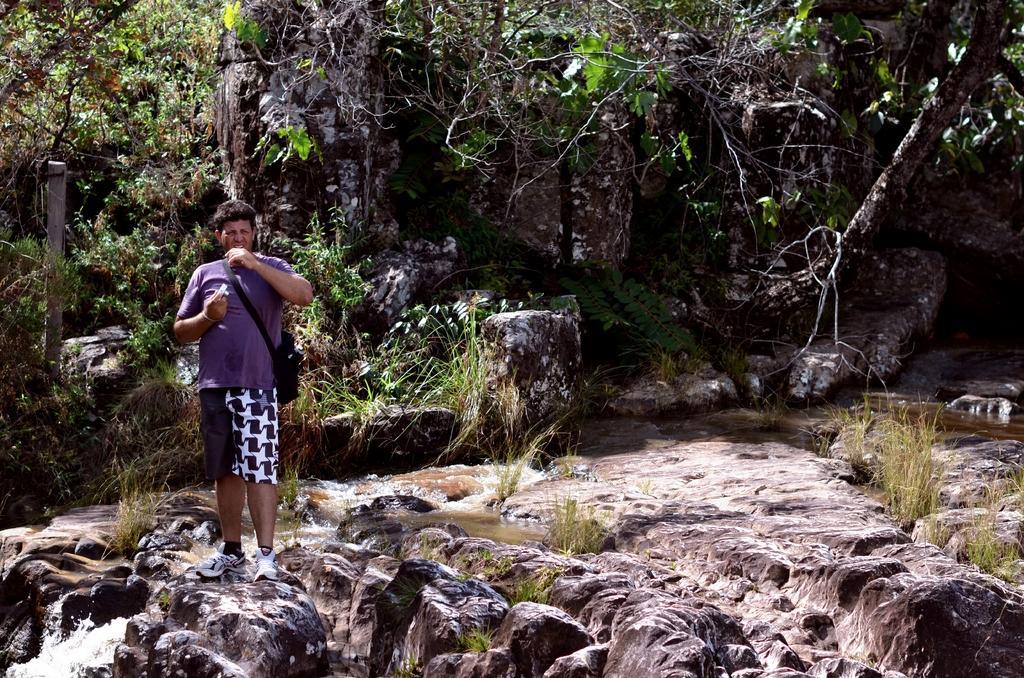Describe this image in one or two sentences. In this image we can see a person wearing the bag and holding an object and standing. We can also see the water, grass, rocks and also the trees and a pole on the left. 